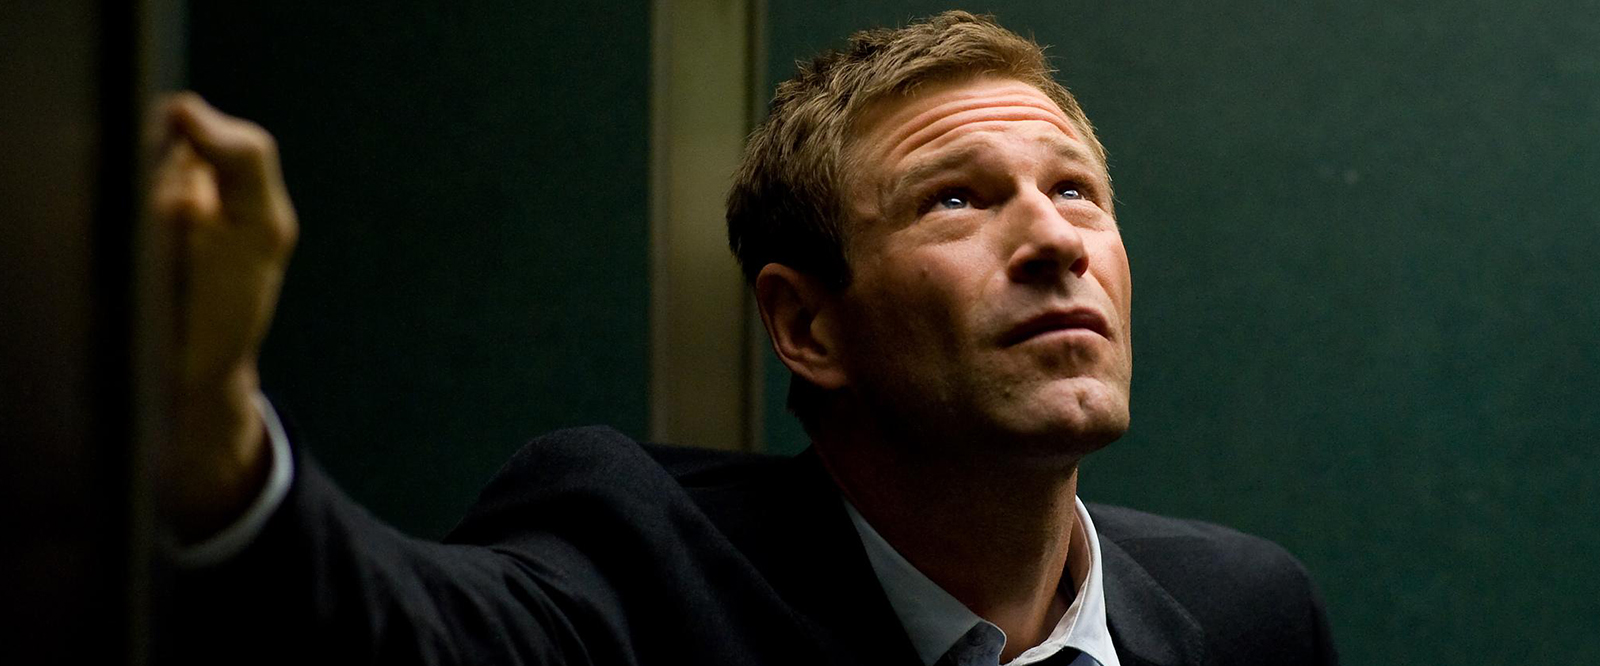Can you tell me more about the setting of this picture? The setting features a green wall that hints at a possibly institutional or office environment. The railing suggests a stairwell or balcony, perhaps on an upper floor given the angle at which the photograph was taken. There's a subtle contrast between the man's formal appearance and the relatively plain and functional background, which might suggest a professional scenario or a formal event taking place within an everyday setting. 